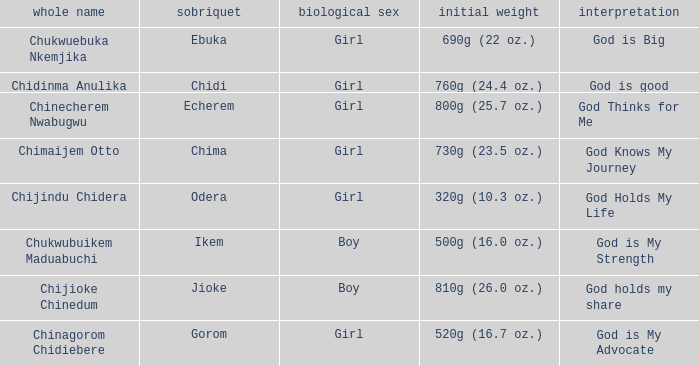How much did the baby who name means God knows my journey weigh at birth? 730g (23.5 oz.). 